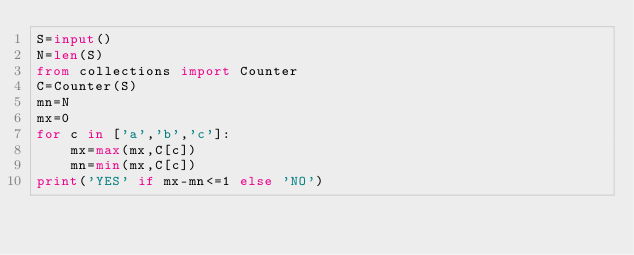Convert code to text. <code><loc_0><loc_0><loc_500><loc_500><_Python_>S=input()
N=len(S)
from collections import Counter
C=Counter(S)
mn=N
mx=0
for c in ['a','b','c']:
    mx=max(mx,C[c])
    mn=min(mx,C[c])
print('YES' if mx-mn<=1 else 'NO')</code> 